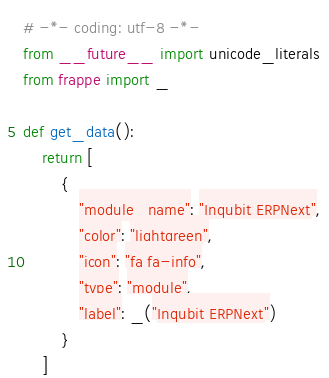<code> <loc_0><loc_0><loc_500><loc_500><_Python_># -*- coding: utf-8 -*-
from __future__ import unicode_literals
from frappe import _

def get_data():
	return [
		{
			"module_name": "Inqubit ERPNext",
			"color": "lightgreen",
			"icon": "fa fa-info",
			"type": "module",
			"label": _("Inqubit ERPNext")
		}
	]
</code> 